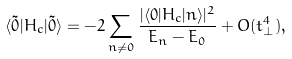Convert formula to latex. <formula><loc_0><loc_0><loc_500><loc_500>\langle \tilde { 0 } | H _ { c } | \tilde { 0 } \rangle = - 2 \sum _ { n \ne 0 } \frac { | \langle 0 | H _ { c } | n \rangle | ^ { 2 } } { E _ { n } - E _ { 0 } } + O ( t _ { \perp } ^ { 4 } ) ,</formula> 